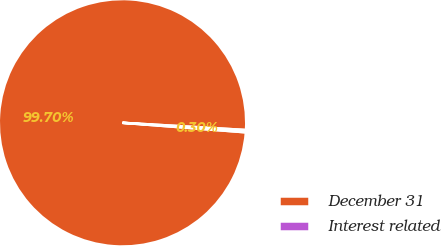<chart> <loc_0><loc_0><loc_500><loc_500><pie_chart><fcel>December 31<fcel>Interest related<nl><fcel>99.7%<fcel>0.3%<nl></chart> 